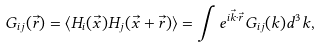<formula> <loc_0><loc_0><loc_500><loc_500>G _ { i j } ( \vec { r } ) = \langle H _ { i } ( \vec { x } ) H _ { j } ( \vec { x } + \vec { r } ) \rangle = \int e ^ { i \vec { k } \cdot \vec { r } } G _ { i j } ( k ) d ^ { 3 } k ,</formula> 